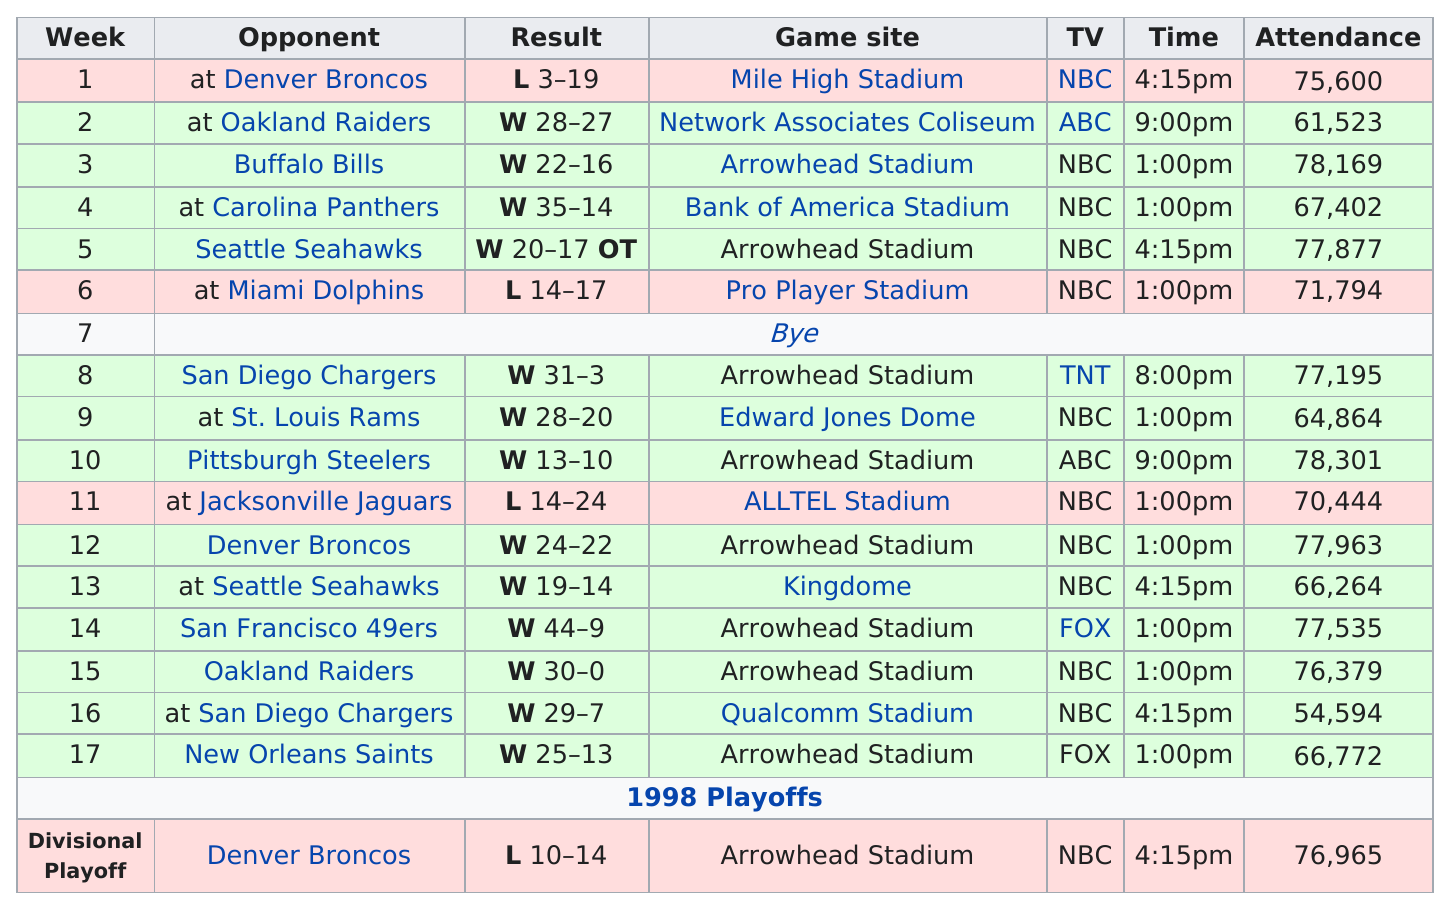Give some essential details in this illustration. Their longest winning streak was 6 games, and we want to maintain that level of success. The tram sustained a total of four losses. In total, the team played 16 games, excluding playoffs, during the season. The Kansas City Chiefs scored the most points in a single game during the 1997 season against the San Francisco 49ers, accumulating a total of (amount of points). The Kansas City Chiefs went into overtime in their 1997 season on week 5. 